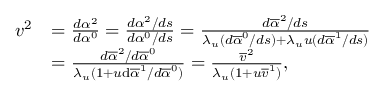<formula> <loc_0><loc_0><loc_500><loc_500>\begin{array} { r l } { v ^ { 2 } } & { = \frac { d \alpha ^ { 2 } } { d \alpha ^ { 0 } } = \frac { d \alpha ^ { 2 } / d s } { d \alpha ^ { 0 } / d s } = \frac { d \overline { \alpha } ^ { 2 } / d s } { \lambda _ { u } ( d \overline { \alpha } ^ { 0 } / d s ) + \lambda _ { u } u ( d \overline { \alpha } ^ { 1 } / d s ) } } \\ & { = \frac { d \overline { \alpha } ^ { 2 } / d \overline { \alpha } ^ { 0 } } { \lambda _ { u } ( 1 + u \mathrm d \overline { \alpha } ^ { 1 } / d \overline { \alpha } ^ { 0 } ) } = \frac { \overline { v } ^ { 2 } } { \lambda _ { u } ( 1 + u \overline { v } ^ { 1 } ) } , } \end{array}</formula> 